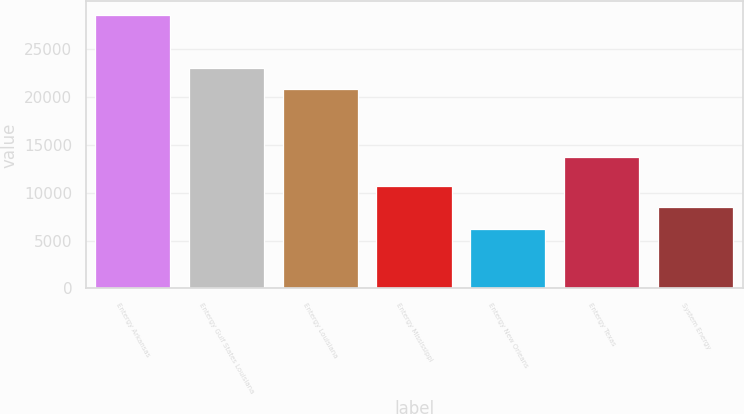Convert chart to OTSL. <chart><loc_0><loc_0><loc_500><loc_500><bar_chart><fcel>Entergy Arkansas<fcel>Entergy Gulf States Louisiana<fcel>Entergy Louisiana<fcel>Entergy Mississippi<fcel>Entergy New Orleans<fcel>Entergy Texas<fcel>System Energy<nl><fcel>28552<fcel>23059.3<fcel>20827<fcel>10693.6<fcel>6229<fcel>13689<fcel>8461.3<nl></chart> 